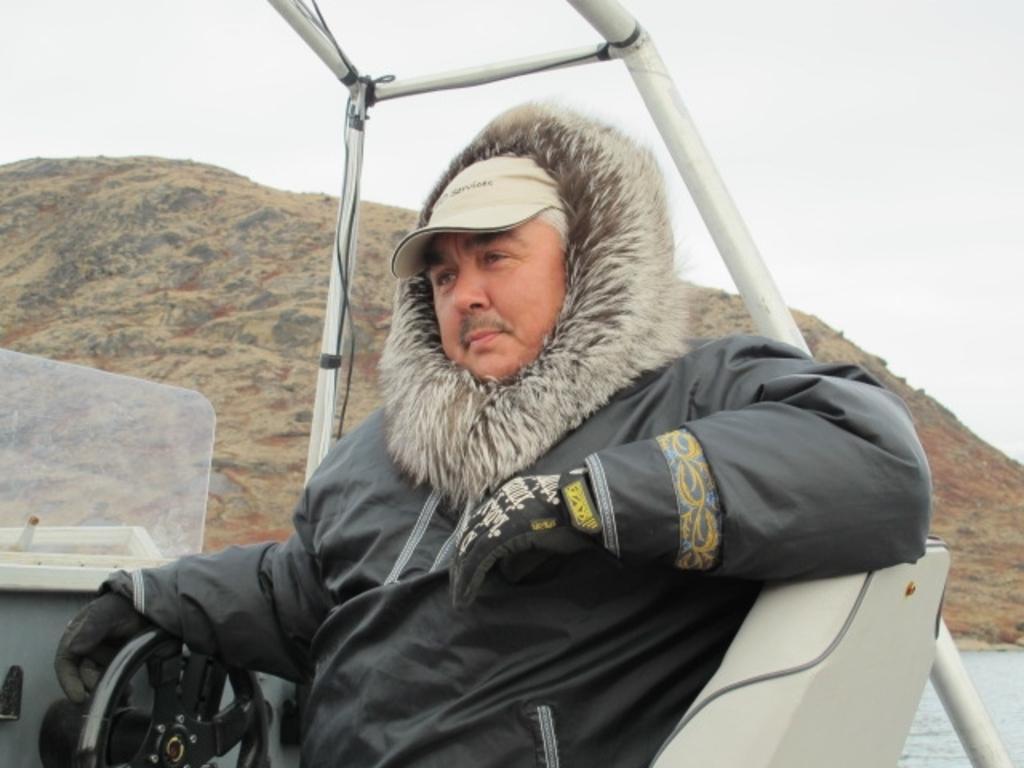In one or two sentences, can you explain what this image depicts? This picture is clicked outside. In the foreground we can see a man wearing jacket and sitting in a vehicle and we can see a steering wheel, mountain, water body and the sky and the metal rods. 